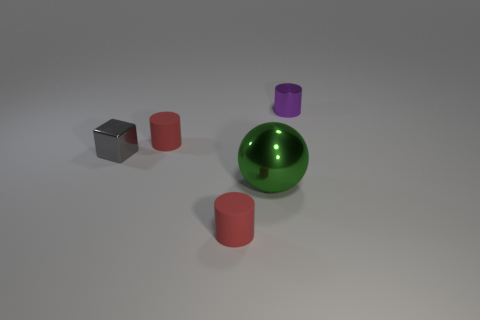Is the shape of the tiny shiny object in front of the purple metallic thing the same as the red object behind the tiny gray block?
Provide a short and direct response. No. How many objects are either small shiny blocks or shiny blocks left of the purple shiny cylinder?
Keep it short and to the point. 1. How many red rubber things have the same size as the shiny block?
Ensure brevity in your answer.  2. What number of yellow objects are either big objects or shiny cubes?
Offer a terse response. 0. The red thing right of the red rubber cylinder behind the metal block is what shape?
Your response must be concise. Cylinder. What shape is the shiny object that is the same size as the gray block?
Give a very brief answer. Cylinder. Are there any small cylinders of the same color as the shiny block?
Ensure brevity in your answer.  No. Is the number of tiny shiny cylinders that are in front of the small purple thing the same as the number of gray blocks that are behind the big green object?
Offer a terse response. No. Is the shape of the small purple shiny object the same as the object in front of the large thing?
Your answer should be compact. Yes. What number of other things are the same material as the tiny purple cylinder?
Your answer should be very brief. 2. 